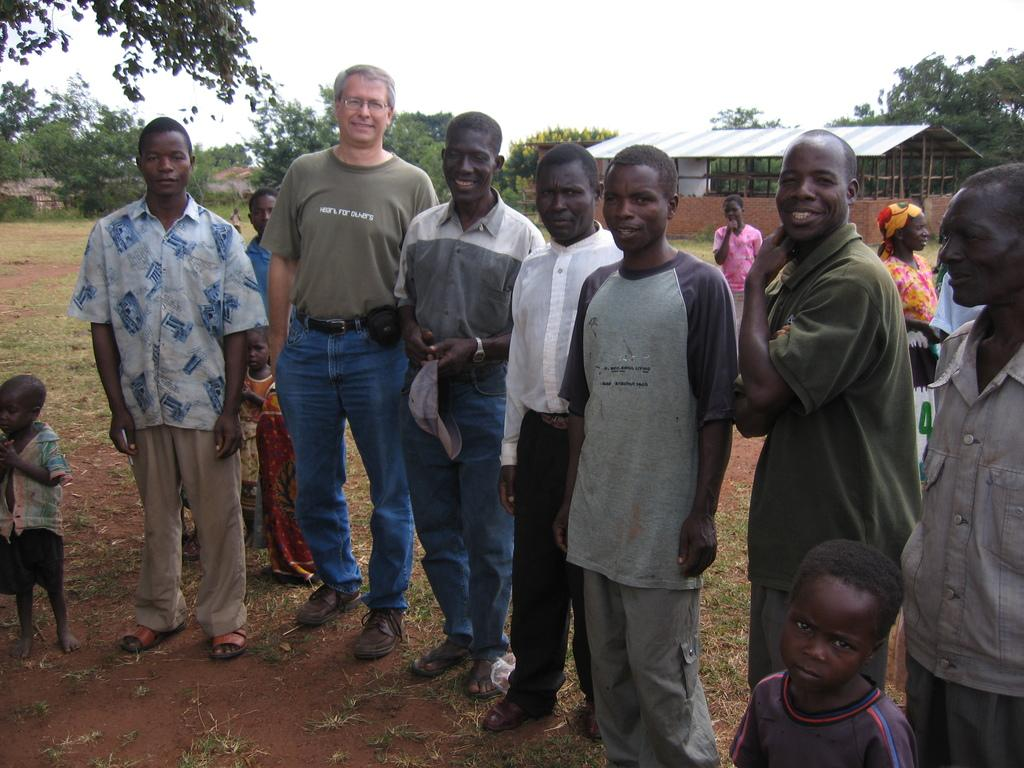What can be seen in the image? There are people standing in the image. What type of natural elements are visible in the image? There are trees visible in the image. What type of structures can be seen in the image? There are sheds in the image. What is visible at the top of the image? The sky is visible at the top of the image. What type of stone is being used to build the history in the image? There is no mention of stone or history in the image; it features people, trees, sheds, and the sky. 